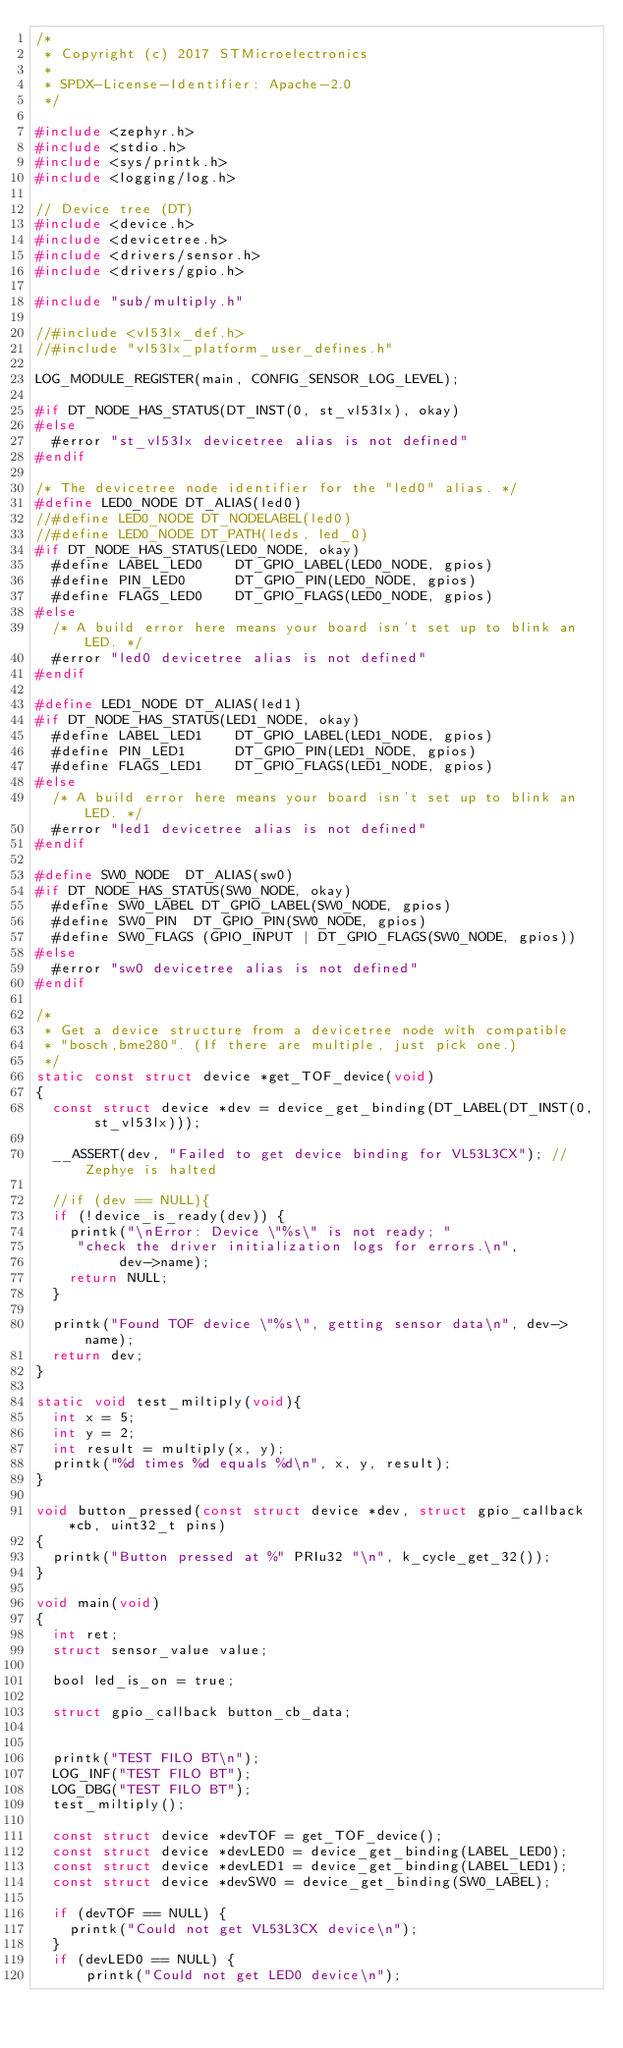<code> <loc_0><loc_0><loc_500><loc_500><_C_>/*
 * Copyright (c) 2017 STMicroelectronics
 *
 * SPDX-License-Identifier: Apache-2.0
 */

#include <zephyr.h>
#include <stdio.h>
#include <sys/printk.h>
#include <logging/log.h>

// Device tree (DT)
#include <device.h>
#include <devicetree.h>
#include <drivers/sensor.h>
#include <drivers/gpio.h>

#include "sub/multiply.h"

//#include <vl53lx_def.h>
//#include "vl53lx_platform_user_defines.h"

LOG_MODULE_REGISTER(main, CONFIG_SENSOR_LOG_LEVEL);

#if DT_NODE_HAS_STATUS(DT_INST(0, st_vl53lx), okay)
#else
  #error "st_vl53lx devicetree alias is not defined"
#endif

/* The devicetree node identifier for the "led0" alias. */
#define LED0_NODE DT_ALIAS(led0)
//#define LED0_NODE DT_NODELABEL(led0)
//#define LED0_NODE DT_PATH(leds, led_0)
#if DT_NODE_HAS_STATUS(LED0_NODE, okay)
  #define LABEL_LED0    DT_GPIO_LABEL(LED0_NODE, gpios)
  #define PIN_LED0      DT_GPIO_PIN(LED0_NODE, gpios)
  #define FLAGS_LED0    DT_GPIO_FLAGS(LED0_NODE, gpios)
#else
  /* A build error here means your board isn't set up to blink an LED. */
  #error "led0 devicetree alias is not defined"
#endif

#define LED1_NODE DT_ALIAS(led1)
#if DT_NODE_HAS_STATUS(LED1_NODE, okay)
  #define LABEL_LED1    DT_GPIO_LABEL(LED1_NODE, gpios)
  #define PIN_LED1      DT_GPIO_PIN(LED1_NODE, gpios)
  #define FLAGS_LED1    DT_GPIO_FLAGS(LED1_NODE, gpios)
#else
  /* A build error here means your board isn't set up to blink an LED. */
  #error "led1 devicetree alias is not defined"
#endif

#define SW0_NODE	DT_ALIAS(sw0)
#if DT_NODE_HAS_STATUS(SW0_NODE, okay)
  #define SW0_LABEL DT_GPIO_LABEL(SW0_NODE, gpios)
  #define SW0_PIN	 DT_GPIO_PIN(SW0_NODE, gpios)
  #define SW0_FLAGS (GPIO_INPUT | DT_GPIO_FLAGS(SW0_NODE, gpios))
#else
  #error "sw0 devicetree alias is not defined"
#endif

/*
 * Get a device structure from a devicetree node with compatible
 * "bosch,bme280". (If there are multiple, just pick one.)
 */
static const struct device *get_TOF_device(void)
{
  const struct device *dev = device_get_binding(DT_LABEL(DT_INST(0, st_vl53lx)));

  __ASSERT(dev, "Failed to get device binding for VL53L3CX"); // Zephye is halted 
  
  //if (dev == NULL){
  if (!device_is_ready(dev)) {
    printk("\nError: Device \"%s\" is not ready; "
	   "check the driver initialization logs for errors.\n",
          dev->name);
    return NULL;
  }

  printk("Found TOF device \"%s\", getting sensor data\n", dev->name);
  return dev;
}

static void test_miltiply(void){
  int x = 5;
  int y = 2;
  int result = multiply(x, y);
  printk("%d times %d equals %d\n", x, y, result);
}

void button_pressed(const struct device *dev, struct gpio_callback *cb, uint32_t pins)
{
  printk("Button pressed at %" PRIu32 "\n", k_cycle_get_32());
}

void main(void)
{
  int ret;
  struct sensor_value value;

  bool led_is_on = true;
  
  struct gpio_callback button_cb_data;


  printk("TEST FILO BT\n");
  LOG_INF("TEST FILO BT");
  LOG_DBG("TEST FILO BT");
  test_miltiply();

  const struct device *devTOF = get_TOF_device();
  const struct device *devLED0 = device_get_binding(LABEL_LED0);
  const struct device *devLED1 = device_get_binding(LABEL_LED1);
  const struct device *devSW0 = device_get_binding(SW0_LABEL);
	
  if (devTOF == NULL) {
    printk("Could not get VL53L3CX device\n");
  }
  if (devLED0 == NULL) {
      printk("Could not get LED0 device\n");</code> 